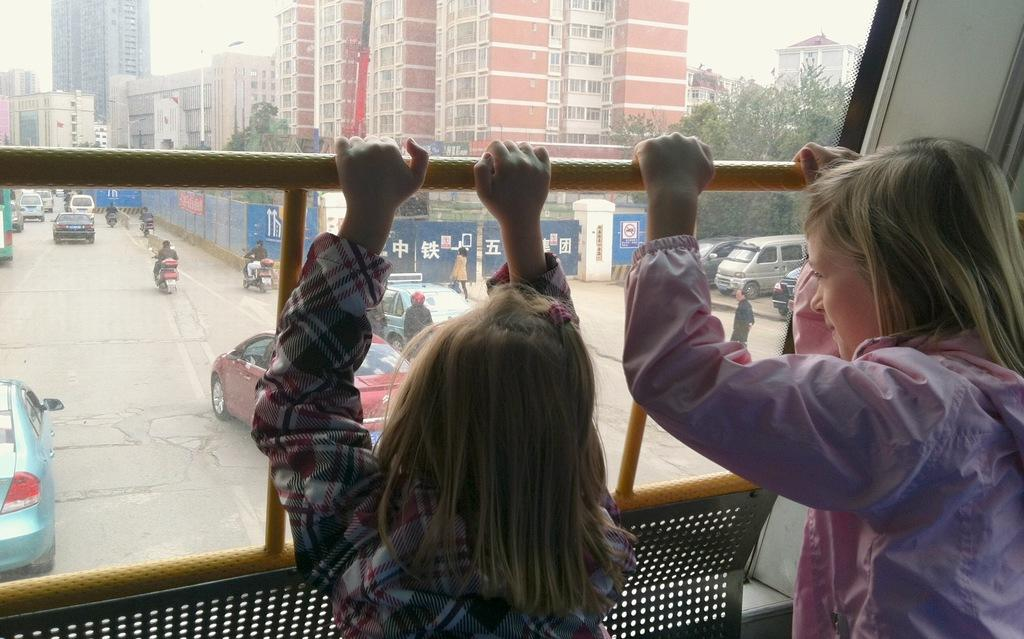What are the two children doing in the image? The two children are holding a rod in the image. What can be seen on the road in the image? There are vehicles on the road in the image. What type of natural elements are present in the image? There are trees in the image. What type of man-made structures can be seen in the image? There are buildings in the image. What is the purpose of the wall in the image? The wall serves as a boundary or barrier in the image. What is visible in the background of the image? The sky is visible in the background of the image. Where is the sofa located in the image? There is no sofa present in the image. What type of bulb is being used by the children to light up the rod? The children are not using any bulbs to light up the rod; they are simply holding it. 